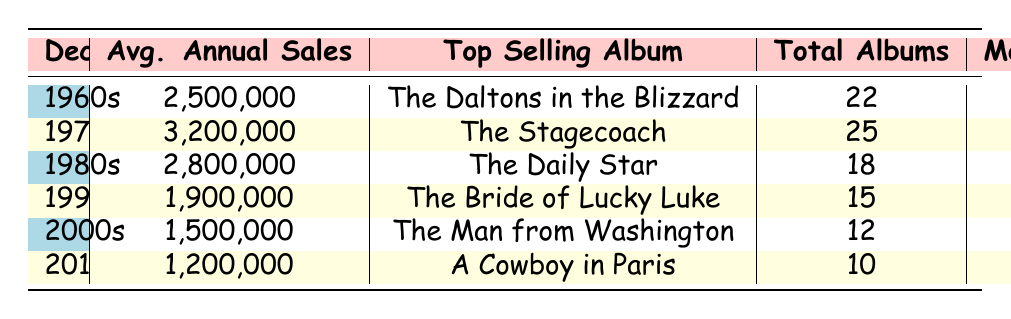What was the top-selling album in the 1970s? The table shows that the top-selling album for the 1970s is "The Stagecoach."
Answer: The Stagecoach Which decade had the highest average annual sales? By examining the average annual sales for each decade, the 1970s has the highest sales at 3,200,000.
Answer: 1970s What is the difference in average annual sales between the 1980s and 2000s? The average annual sales for the 1980s is 2,800,000 and for the 2000s is 1,500,000. The difference is 2,800,000 - 1,500,000 = 1,300,000.
Answer: 1,300,000 True or False: Jolly Jumper was the most popular character in the 1990s. The table indicates that in the 1990s, the most popular character was "The Daltons," not Jolly Jumper.
Answer: False How many total albums were released in the 1960s and 1970s combined? To find the total, add the number of albums from both decades: 22 (1960s) + 25 (1970s) = 47.
Answer: 47 What was the average annual sales trend from the 1990s to the 2010s? Looking at the average annual sales, it shows a decline from 1,900,000 (1990s) to 1,200,000 (2010s). Specifically, the values are 1,900,000, 1,500,000, and 1,200,000, indicating a decreasing trend.
Answer: Decreasing trend What was the most popular character across all decades represented in the data? By examining the table, we see that different characters were most popular in each decade, so there is no single character that holds this title across all decades.
Answer: None True or False: "A Cowboy in Paris" was released in the 2000s. According to the table, "A Cowboy in Paris" is listed under the 2010s and not the 2000s, making the statement false.
Answer: False 